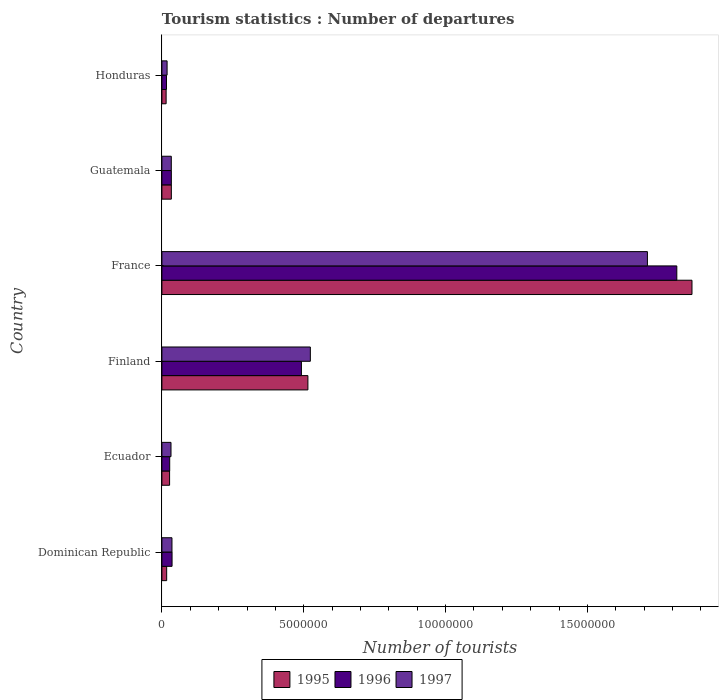How many groups of bars are there?
Keep it short and to the point. 6. Are the number of bars per tick equal to the number of legend labels?
Provide a short and direct response. Yes. How many bars are there on the 6th tick from the top?
Keep it short and to the point. 3. How many bars are there on the 6th tick from the bottom?
Provide a succinct answer. 3. What is the label of the 6th group of bars from the top?
Provide a succinct answer. Dominican Republic. What is the number of tourist departures in 1997 in Ecuador?
Ensure brevity in your answer.  3.21e+05. Across all countries, what is the maximum number of tourist departures in 1996?
Keep it short and to the point. 1.82e+07. Across all countries, what is the minimum number of tourist departures in 1996?
Your answer should be very brief. 1.62e+05. In which country was the number of tourist departures in 1996 maximum?
Ensure brevity in your answer.  France. In which country was the number of tourist departures in 1996 minimum?
Your answer should be compact. Honduras. What is the total number of tourist departures in 1997 in the graph?
Your answer should be compact. 2.35e+07. What is the difference between the number of tourist departures in 1996 in Dominican Republic and that in Guatemala?
Make the answer very short. 2.50e+04. What is the difference between the number of tourist departures in 1996 in Honduras and the number of tourist departures in 1997 in France?
Your response must be concise. -1.70e+07. What is the average number of tourist departures in 1995 per country?
Offer a terse response. 4.13e+06. What is the difference between the number of tourist departures in 1995 and number of tourist departures in 1996 in Guatemala?
Offer a terse response. 0. In how many countries, is the number of tourist departures in 1996 greater than 4000000 ?
Offer a terse response. 2. What is the ratio of the number of tourist departures in 1995 in Dominican Republic to that in Finland?
Offer a terse response. 0.03. Is the number of tourist departures in 1996 in Finland less than that in France?
Provide a short and direct response. Yes. Is the difference between the number of tourist departures in 1995 in Finland and France greater than the difference between the number of tourist departures in 1996 in Finland and France?
Give a very brief answer. No. What is the difference between the highest and the second highest number of tourist departures in 1996?
Keep it short and to the point. 1.32e+07. What is the difference between the highest and the lowest number of tourist departures in 1996?
Keep it short and to the point. 1.80e+07. What does the 3rd bar from the top in Honduras represents?
Your answer should be very brief. 1995. What does the 2nd bar from the bottom in Finland represents?
Give a very brief answer. 1996. How many bars are there?
Ensure brevity in your answer.  18. Are all the bars in the graph horizontal?
Provide a succinct answer. Yes. Are the values on the major ticks of X-axis written in scientific E-notation?
Your answer should be very brief. No. Where does the legend appear in the graph?
Provide a short and direct response. Bottom center. What is the title of the graph?
Offer a very short reply. Tourism statistics : Number of departures. What is the label or title of the X-axis?
Keep it short and to the point. Number of tourists. What is the Number of tourists of 1995 in Dominican Republic?
Ensure brevity in your answer.  1.68e+05. What is the Number of tourists in 1996 in Dominican Republic?
Your answer should be compact. 3.58e+05. What is the Number of tourists of 1997 in Dominican Republic?
Make the answer very short. 3.55e+05. What is the Number of tourists in 1995 in Ecuador?
Offer a very short reply. 2.71e+05. What is the Number of tourists of 1996 in Ecuador?
Offer a terse response. 2.75e+05. What is the Number of tourists of 1997 in Ecuador?
Offer a very short reply. 3.21e+05. What is the Number of tourists of 1995 in Finland?
Provide a short and direct response. 5.15e+06. What is the Number of tourists of 1996 in Finland?
Offer a terse response. 4.92e+06. What is the Number of tourists in 1997 in Finland?
Give a very brief answer. 5.23e+06. What is the Number of tourists of 1995 in France?
Make the answer very short. 1.87e+07. What is the Number of tourists of 1996 in France?
Your answer should be compact. 1.82e+07. What is the Number of tourists of 1997 in France?
Provide a succinct answer. 1.71e+07. What is the Number of tourists in 1995 in Guatemala?
Your answer should be very brief. 3.33e+05. What is the Number of tourists of 1996 in Guatemala?
Your response must be concise. 3.33e+05. What is the Number of tourists of 1997 in Guatemala?
Your response must be concise. 3.31e+05. What is the Number of tourists of 1995 in Honduras?
Provide a succinct answer. 1.49e+05. What is the Number of tourists in 1996 in Honduras?
Keep it short and to the point. 1.62e+05. What is the Number of tourists of 1997 in Honduras?
Keep it short and to the point. 1.83e+05. Across all countries, what is the maximum Number of tourists in 1995?
Your response must be concise. 1.87e+07. Across all countries, what is the maximum Number of tourists of 1996?
Provide a succinct answer. 1.82e+07. Across all countries, what is the maximum Number of tourists of 1997?
Your answer should be very brief. 1.71e+07. Across all countries, what is the minimum Number of tourists in 1995?
Offer a terse response. 1.49e+05. Across all countries, what is the minimum Number of tourists of 1996?
Provide a succinct answer. 1.62e+05. Across all countries, what is the minimum Number of tourists of 1997?
Offer a very short reply. 1.83e+05. What is the total Number of tourists of 1995 in the graph?
Keep it short and to the point. 2.48e+07. What is the total Number of tourists in 1996 in the graph?
Provide a succinct answer. 2.42e+07. What is the total Number of tourists in 1997 in the graph?
Your answer should be very brief. 2.35e+07. What is the difference between the Number of tourists in 1995 in Dominican Republic and that in Ecuador?
Your answer should be very brief. -1.03e+05. What is the difference between the Number of tourists of 1996 in Dominican Republic and that in Ecuador?
Offer a terse response. 8.30e+04. What is the difference between the Number of tourists of 1997 in Dominican Republic and that in Ecuador?
Your response must be concise. 3.40e+04. What is the difference between the Number of tourists of 1995 in Dominican Republic and that in Finland?
Provide a short and direct response. -4.98e+06. What is the difference between the Number of tourists in 1996 in Dominican Republic and that in Finland?
Ensure brevity in your answer.  -4.56e+06. What is the difference between the Number of tourists in 1997 in Dominican Republic and that in Finland?
Offer a very short reply. -4.88e+06. What is the difference between the Number of tourists of 1995 in Dominican Republic and that in France?
Offer a terse response. -1.85e+07. What is the difference between the Number of tourists in 1996 in Dominican Republic and that in France?
Your answer should be very brief. -1.78e+07. What is the difference between the Number of tourists of 1997 in Dominican Republic and that in France?
Your answer should be very brief. -1.68e+07. What is the difference between the Number of tourists of 1995 in Dominican Republic and that in Guatemala?
Keep it short and to the point. -1.65e+05. What is the difference between the Number of tourists in 1996 in Dominican Republic and that in Guatemala?
Your answer should be compact. 2.50e+04. What is the difference between the Number of tourists in 1997 in Dominican Republic and that in Guatemala?
Your answer should be very brief. 2.40e+04. What is the difference between the Number of tourists of 1995 in Dominican Republic and that in Honduras?
Provide a short and direct response. 1.90e+04. What is the difference between the Number of tourists in 1996 in Dominican Republic and that in Honduras?
Provide a succinct answer. 1.96e+05. What is the difference between the Number of tourists of 1997 in Dominican Republic and that in Honduras?
Make the answer very short. 1.72e+05. What is the difference between the Number of tourists of 1995 in Ecuador and that in Finland?
Offer a terse response. -4.88e+06. What is the difference between the Number of tourists of 1996 in Ecuador and that in Finland?
Give a very brief answer. -4.64e+06. What is the difference between the Number of tourists of 1997 in Ecuador and that in Finland?
Make the answer very short. -4.91e+06. What is the difference between the Number of tourists of 1995 in Ecuador and that in France?
Provide a short and direct response. -1.84e+07. What is the difference between the Number of tourists in 1996 in Ecuador and that in France?
Your response must be concise. -1.79e+07. What is the difference between the Number of tourists in 1997 in Ecuador and that in France?
Your answer should be very brief. -1.68e+07. What is the difference between the Number of tourists in 1995 in Ecuador and that in Guatemala?
Ensure brevity in your answer.  -6.20e+04. What is the difference between the Number of tourists of 1996 in Ecuador and that in Guatemala?
Provide a short and direct response. -5.80e+04. What is the difference between the Number of tourists in 1995 in Ecuador and that in Honduras?
Make the answer very short. 1.22e+05. What is the difference between the Number of tourists of 1996 in Ecuador and that in Honduras?
Offer a very short reply. 1.13e+05. What is the difference between the Number of tourists in 1997 in Ecuador and that in Honduras?
Offer a terse response. 1.38e+05. What is the difference between the Number of tourists of 1995 in Finland and that in France?
Provide a succinct answer. -1.35e+07. What is the difference between the Number of tourists of 1996 in Finland and that in France?
Offer a terse response. -1.32e+07. What is the difference between the Number of tourists of 1997 in Finland and that in France?
Your answer should be compact. -1.19e+07. What is the difference between the Number of tourists of 1995 in Finland and that in Guatemala?
Your answer should be very brief. 4.81e+06. What is the difference between the Number of tourists in 1996 in Finland and that in Guatemala?
Your answer should be compact. 4.58e+06. What is the difference between the Number of tourists of 1997 in Finland and that in Guatemala?
Provide a short and direct response. 4.90e+06. What is the difference between the Number of tourists in 1995 in Finland and that in Honduras?
Your answer should be compact. 5.00e+06. What is the difference between the Number of tourists in 1996 in Finland and that in Honduras?
Your answer should be compact. 4.76e+06. What is the difference between the Number of tourists of 1997 in Finland and that in Honduras?
Give a very brief answer. 5.05e+06. What is the difference between the Number of tourists of 1995 in France and that in Guatemala?
Your response must be concise. 1.84e+07. What is the difference between the Number of tourists in 1996 in France and that in Guatemala?
Ensure brevity in your answer.  1.78e+07. What is the difference between the Number of tourists of 1997 in France and that in Guatemala?
Your response must be concise. 1.68e+07. What is the difference between the Number of tourists of 1995 in France and that in Honduras?
Your answer should be very brief. 1.85e+07. What is the difference between the Number of tourists in 1996 in France and that in Honduras?
Your answer should be very brief. 1.80e+07. What is the difference between the Number of tourists of 1997 in France and that in Honduras?
Your response must be concise. 1.69e+07. What is the difference between the Number of tourists of 1995 in Guatemala and that in Honduras?
Give a very brief answer. 1.84e+05. What is the difference between the Number of tourists in 1996 in Guatemala and that in Honduras?
Offer a terse response. 1.71e+05. What is the difference between the Number of tourists in 1997 in Guatemala and that in Honduras?
Your response must be concise. 1.48e+05. What is the difference between the Number of tourists in 1995 in Dominican Republic and the Number of tourists in 1996 in Ecuador?
Your response must be concise. -1.07e+05. What is the difference between the Number of tourists in 1995 in Dominican Republic and the Number of tourists in 1997 in Ecuador?
Provide a short and direct response. -1.53e+05. What is the difference between the Number of tourists in 1996 in Dominican Republic and the Number of tourists in 1997 in Ecuador?
Provide a short and direct response. 3.70e+04. What is the difference between the Number of tourists in 1995 in Dominican Republic and the Number of tourists in 1996 in Finland?
Give a very brief answer. -4.75e+06. What is the difference between the Number of tourists of 1995 in Dominican Republic and the Number of tourists of 1997 in Finland?
Offer a terse response. -5.06e+06. What is the difference between the Number of tourists in 1996 in Dominican Republic and the Number of tourists in 1997 in Finland?
Offer a very short reply. -4.88e+06. What is the difference between the Number of tourists in 1995 in Dominican Republic and the Number of tourists in 1996 in France?
Make the answer very short. -1.80e+07. What is the difference between the Number of tourists in 1995 in Dominican Republic and the Number of tourists in 1997 in France?
Provide a succinct answer. -1.69e+07. What is the difference between the Number of tourists of 1996 in Dominican Republic and the Number of tourists of 1997 in France?
Your answer should be compact. -1.68e+07. What is the difference between the Number of tourists of 1995 in Dominican Republic and the Number of tourists of 1996 in Guatemala?
Keep it short and to the point. -1.65e+05. What is the difference between the Number of tourists in 1995 in Dominican Republic and the Number of tourists in 1997 in Guatemala?
Provide a succinct answer. -1.63e+05. What is the difference between the Number of tourists of 1996 in Dominican Republic and the Number of tourists of 1997 in Guatemala?
Your answer should be very brief. 2.70e+04. What is the difference between the Number of tourists of 1995 in Dominican Republic and the Number of tourists of 1996 in Honduras?
Give a very brief answer. 6000. What is the difference between the Number of tourists in 1995 in Dominican Republic and the Number of tourists in 1997 in Honduras?
Offer a terse response. -1.50e+04. What is the difference between the Number of tourists of 1996 in Dominican Republic and the Number of tourists of 1997 in Honduras?
Make the answer very short. 1.75e+05. What is the difference between the Number of tourists in 1995 in Ecuador and the Number of tourists in 1996 in Finland?
Your answer should be very brief. -4.65e+06. What is the difference between the Number of tourists in 1995 in Ecuador and the Number of tourists in 1997 in Finland?
Your answer should be very brief. -4.96e+06. What is the difference between the Number of tourists of 1996 in Ecuador and the Number of tourists of 1997 in Finland?
Ensure brevity in your answer.  -4.96e+06. What is the difference between the Number of tourists in 1995 in Ecuador and the Number of tourists in 1996 in France?
Your response must be concise. -1.79e+07. What is the difference between the Number of tourists of 1995 in Ecuador and the Number of tourists of 1997 in France?
Offer a terse response. -1.68e+07. What is the difference between the Number of tourists of 1996 in Ecuador and the Number of tourists of 1997 in France?
Give a very brief answer. -1.68e+07. What is the difference between the Number of tourists of 1995 in Ecuador and the Number of tourists of 1996 in Guatemala?
Your answer should be very brief. -6.20e+04. What is the difference between the Number of tourists of 1996 in Ecuador and the Number of tourists of 1997 in Guatemala?
Provide a short and direct response. -5.60e+04. What is the difference between the Number of tourists of 1995 in Ecuador and the Number of tourists of 1996 in Honduras?
Keep it short and to the point. 1.09e+05. What is the difference between the Number of tourists of 1995 in Ecuador and the Number of tourists of 1997 in Honduras?
Offer a very short reply. 8.80e+04. What is the difference between the Number of tourists of 1996 in Ecuador and the Number of tourists of 1997 in Honduras?
Your answer should be very brief. 9.20e+04. What is the difference between the Number of tourists in 1995 in Finland and the Number of tourists in 1996 in France?
Ensure brevity in your answer.  -1.30e+07. What is the difference between the Number of tourists of 1995 in Finland and the Number of tourists of 1997 in France?
Provide a short and direct response. -1.20e+07. What is the difference between the Number of tourists in 1996 in Finland and the Number of tourists in 1997 in France?
Offer a terse response. -1.22e+07. What is the difference between the Number of tourists of 1995 in Finland and the Number of tourists of 1996 in Guatemala?
Your answer should be very brief. 4.81e+06. What is the difference between the Number of tourists of 1995 in Finland and the Number of tourists of 1997 in Guatemala?
Provide a succinct answer. 4.82e+06. What is the difference between the Number of tourists of 1996 in Finland and the Number of tourists of 1997 in Guatemala?
Keep it short and to the point. 4.59e+06. What is the difference between the Number of tourists of 1995 in Finland and the Number of tourists of 1996 in Honduras?
Make the answer very short. 4.98e+06. What is the difference between the Number of tourists of 1995 in Finland and the Number of tourists of 1997 in Honduras?
Provide a short and direct response. 4.96e+06. What is the difference between the Number of tourists in 1996 in Finland and the Number of tourists in 1997 in Honduras?
Your response must be concise. 4.74e+06. What is the difference between the Number of tourists in 1995 in France and the Number of tourists in 1996 in Guatemala?
Give a very brief answer. 1.84e+07. What is the difference between the Number of tourists in 1995 in France and the Number of tourists in 1997 in Guatemala?
Provide a short and direct response. 1.84e+07. What is the difference between the Number of tourists of 1996 in France and the Number of tourists of 1997 in Guatemala?
Your answer should be very brief. 1.78e+07. What is the difference between the Number of tourists of 1995 in France and the Number of tourists of 1996 in Honduras?
Your answer should be very brief. 1.85e+07. What is the difference between the Number of tourists in 1995 in France and the Number of tourists in 1997 in Honduras?
Provide a short and direct response. 1.85e+07. What is the difference between the Number of tourists in 1996 in France and the Number of tourists in 1997 in Honduras?
Your answer should be compact. 1.80e+07. What is the difference between the Number of tourists in 1995 in Guatemala and the Number of tourists in 1996 in Honduras?
Keep it short and to the point. 1.71e+05. What is the difference between the Number of tourists in 1995 in Guatemala and the Number of tourists in 1997 in Honduras?
Your answer should be very brief. 1.50e+05. What is the difference between the Number of tourists in 1996 in Guatemala and the Number of tourists in 1997 in Honduras?
Make the answer very short. 1.50e+05. What is the average Number of tourists in 1995 per country?
Your response must be concise. 4.13e+06. What is the average Number of tourists of 1996 per country?
Keep it short and to the point. 4.03e+06. What is the average Number of tourists of 1997 per country?
Ensure brevity in your answer.  3.92e+06. What is the difference between the Number of tourists of 1995 and Number of tourists of 1996 in Dominican Republic?
Offer a very short reply. -1.90e+05. What is the difference between the Number of tourists in 1995 and Number of tourists in 1997 in Dominican Republic?
Make the answer very short. -1.87e+05. What is the difference between the Number of tourists in 1996 and Number of tourists in 1997 in Dominican Republic?
Give a very brief answer. 3000. What is the difference between the Number of tourists in 1995 and Number of tourists in 1996 in Ecuador?
Make the answer very short. -4000. What is the difference between the Number of tourists of 1996 and Number of tourists of 1997 in Ecuador?
Your answer should be compact. -4.60e+04. What is the difference between the Number of tourists of 1995 and Number of tourists of 1996 in Finland?
Ensure brevity in your answer.  2.29e+05. What is the difference between the Number of tourists of 1995 and Number of tourists of 1997 in Finland?
Your answer should be very brief. -8.60e+04. What is the difference between the Number of tourists of 1996 and Number of tourists of 1997 in Finland?
Provide a succinct answer. -3.15e+05. What is the difference between the Number of tourists in 1995 and Number of tourists in 1996 in France?
Ensure brevity in your answer.  5.35e+05. What is the difference between the Number of tourists of 1995 and Number of tourists of 1997 in France?
Provide a succinct answer. 1.57e+06. What is the difference between the Number of tourists in 1996 and Number of tourists in 1997 in France?
Give a very brief answer. 1.04e+06. What is the difference between the Number of tourists in 1995 and Number of tourists in 1996 in Guatemala?
Offer a terse response. 0. What is the difference between the Number of tourists of 1995 and Number of tourists of 1996 in Honduras?
Your response must be concise. -1.30e+04. What is the difference between the Number of tourists of 1995 and Number of tourists of 1997 in Honduras?
Make the answer very short. -3.40e+04. What is the difference between the Number of tourists of 1996 and Number of tourists of 1997 in Honduras?
Provide a succinct answer. -2.10e+04. What is the ratio of the Number of tourists of 1995 in Dominican Republic to that in Ecuador?
Offer a terse response. 0.62. What is the ratio of the Number of tourists in 1996 in Dominican Republic to that in Ecuador?
Make the answer very short. 1.3. What is the ratio of the Number of tourists of 1997 in Dominican Republic to that in Ecuador?
Provide a succinct answer. 1.11. What is the ratio of the Number of tourists of 1995 in Dominican Republic to that in Finland?
Provide a short and direct response. 0.03. What is the ratio of the Number of tourists of 1996 in Dominican Republic to that in Finland?
Keep it short and to the point. 0.07. What is the ratio of the Number of tourists of 1997 in Dominican Republic to that in Finland?
Your answer should be compact. 0.07. What is the ratio of the Number of tourists in 1995 in Dominican Republic to that in France?
Make the answer very short. 0.01. What is the ratio of the Number of tourists of 1996 in Dominican Republic to that in France?
Make the answer very short. 0.02. What is the ratio of the Number of tourists of 1997 in Dominican Republic to that in France?
Your response must be concise. 0.02. What is the ratio of the Number of tourists in 1995 in Dominican Republic to that in Guatemala?
Ensure brevity in your answer.  0.5. What is the ratio of the Number of tourists in 1996 in Dominican Republic to that in Guatemala?
Offer a terse response. 1.08. What is the ratio of the Number of tourists of 1997 in Dominican Republic to that in Guatemala?
Offer a very short reply. 1.07. What is the ratio of the Number of tourists in 1995 in Dominican Republic to that in Honduras?
Keep it short and to the point. 1.13. What is the ratio of the Number of tourists in 1996 in Dominican Republic to that in Honduras?
Ensure brevity in your answer.  2.21. What is the ratio of the Number of tourists in 1997 in Dominican Republic to that in Honduras?
Your answer should be very brief. 1.94. What is the ratio of the Number of tourists in 1995 in Ecuador to that in Finland?
Ensure brevity in your answer.  0.05. What is the ratio of the Number of tourists of 1996 in Ecuador to that in Finland?
Keep it short and to the point. 0.06. What is the ratio of the Number of tourists of 1997 in Ecuador to that in Finland?
Ensure brevity in your answer.  0.06. What is the ratio of the Number of tourists in 1995 in Ecuador to that in France?
Provide a succinct answer. 0.01. What is the ratio of the Number of tourists in 1996 in Ecuador to that in France?
Keep it short and to the point. 0.02. What is the ratio of the Number of tourists in 1997 in Ecuador to that in France?
Your answer should be very brief. 0.02. What is the ratio of the Number of tourists in 1995 in Ecuador to that in Guatemala?
Your response must be concise. 0.81. What is the ratio of the Number of tourists in 1996 in Ecuador to that in Guatemala?
Ensure brevity in your answer.  0.83. What is the ratio of the Number of tourists in 1997 in Ecuador to that in Guatemala?
Your response must be concise. 0.97. What is the ratio of the Number of tourists in 1995 in Ecuador to that in Honduras?
Offer a very short reply. 1.82. What is the ratio of the Number of tourists in 1996 in Ecuador to that in Honduras?
Keep it short and to the point. 1.7. What is the ratio of the Number of tourists in 1997 in Ecuador to that in Honduras?
Your response must be concise. 1.75. What is the ratio of the Number of tourists in 1995 in Finland to that in France?
Give a very brief answer. 0.28. What is the ratio of the Number of tourists in 1996 in Finland to that in France?
Ensure brevity in your answer.  0.27. What is the ratio of the Number of tourists of 1997 in Finland to that in France?
Your answer should be compact. 0.31. What is the ratio of the Number of tourists of 1995 in Finland to that in Guatemala?
Keep it short and to the point. 15.46. What is the ratio of the Number of tourists in 1996 in Finland to that in Guatemala?
Your answer should be compact. 14.77. What is the ratio of the Number of tourists of 1997 in Finland to that in Guatemala?
Make the answer very short. 15.81. What is the ratio of the Number of tourists in 1995 in Finland to that in Honduras?
Offer a very short reply. 34.54. What is the ratio of the Number of tourists in 1996 in Finland to that in Honduras?
Give a very brief answer. 30.36. What is the ratio of the Number of tourists in 1997 in Finland to that in Honduras?
Provide a succinct answer. 28.6. What is the ratio of the Number of tourists in 1995 in France to that in Guatemala?
Ensure brevity in your answer.  56.11. What is the ratio of the Number of tourists of 1996 in France to that in Guatemala?
Your answer should be compact. 54.51. What is the ratio of the Number of tourists in 1997 in France to that in Guatemala?
Your answer should be compact. 51.71. What is the ratio of the Number of tourists in 1995 in France to that in Honduras?
Offer a very short reply. 125.41. What is the ratio of the Number of tourists of 1996 in France to that in Honduras?
Give a very brief answer. 112.04. What is the ratio of the Number of tourists of 1997 in France to that in Honduras?
Offer a terse response. 93.52. What is the ratio of the Number of tourists of 1995 in Guatemala to that in Honduras?
Provide a short and direct response. 2.23. What is the ratio of the Number of tourists in 1996 in Guatemala to that in Honduras?
Offer a terse response. 2.06. What is the ratio of the Number of tourists of 1997 in Guatemala to that in Honduras?
Your answer should be compact. 1.81. What is the difference between the highest and the second highest Number of tourists of 1995?
Provide a succinct answer. 1.35e+07. What is the difference between the highest and the second highest Number of tourists of 1996?
Your answer should be compact. 1.32e+07. What is the difference between the highest and the second highest Number of tourists of 1997?
Offer a very short reply. 1.19e+07. What is the difference between the highest and the lowest Number of tourists in 1995?
Give a very brief answer. 1.85e+07. What is the difference between the highest and the lowest Number of tourists of 1996?
Provide a succinct answer. 1.80e+07. What is the difference between the highest and the lowest Number of tourists in 1997?
Provide a succinct answer. 1.69e+07. 